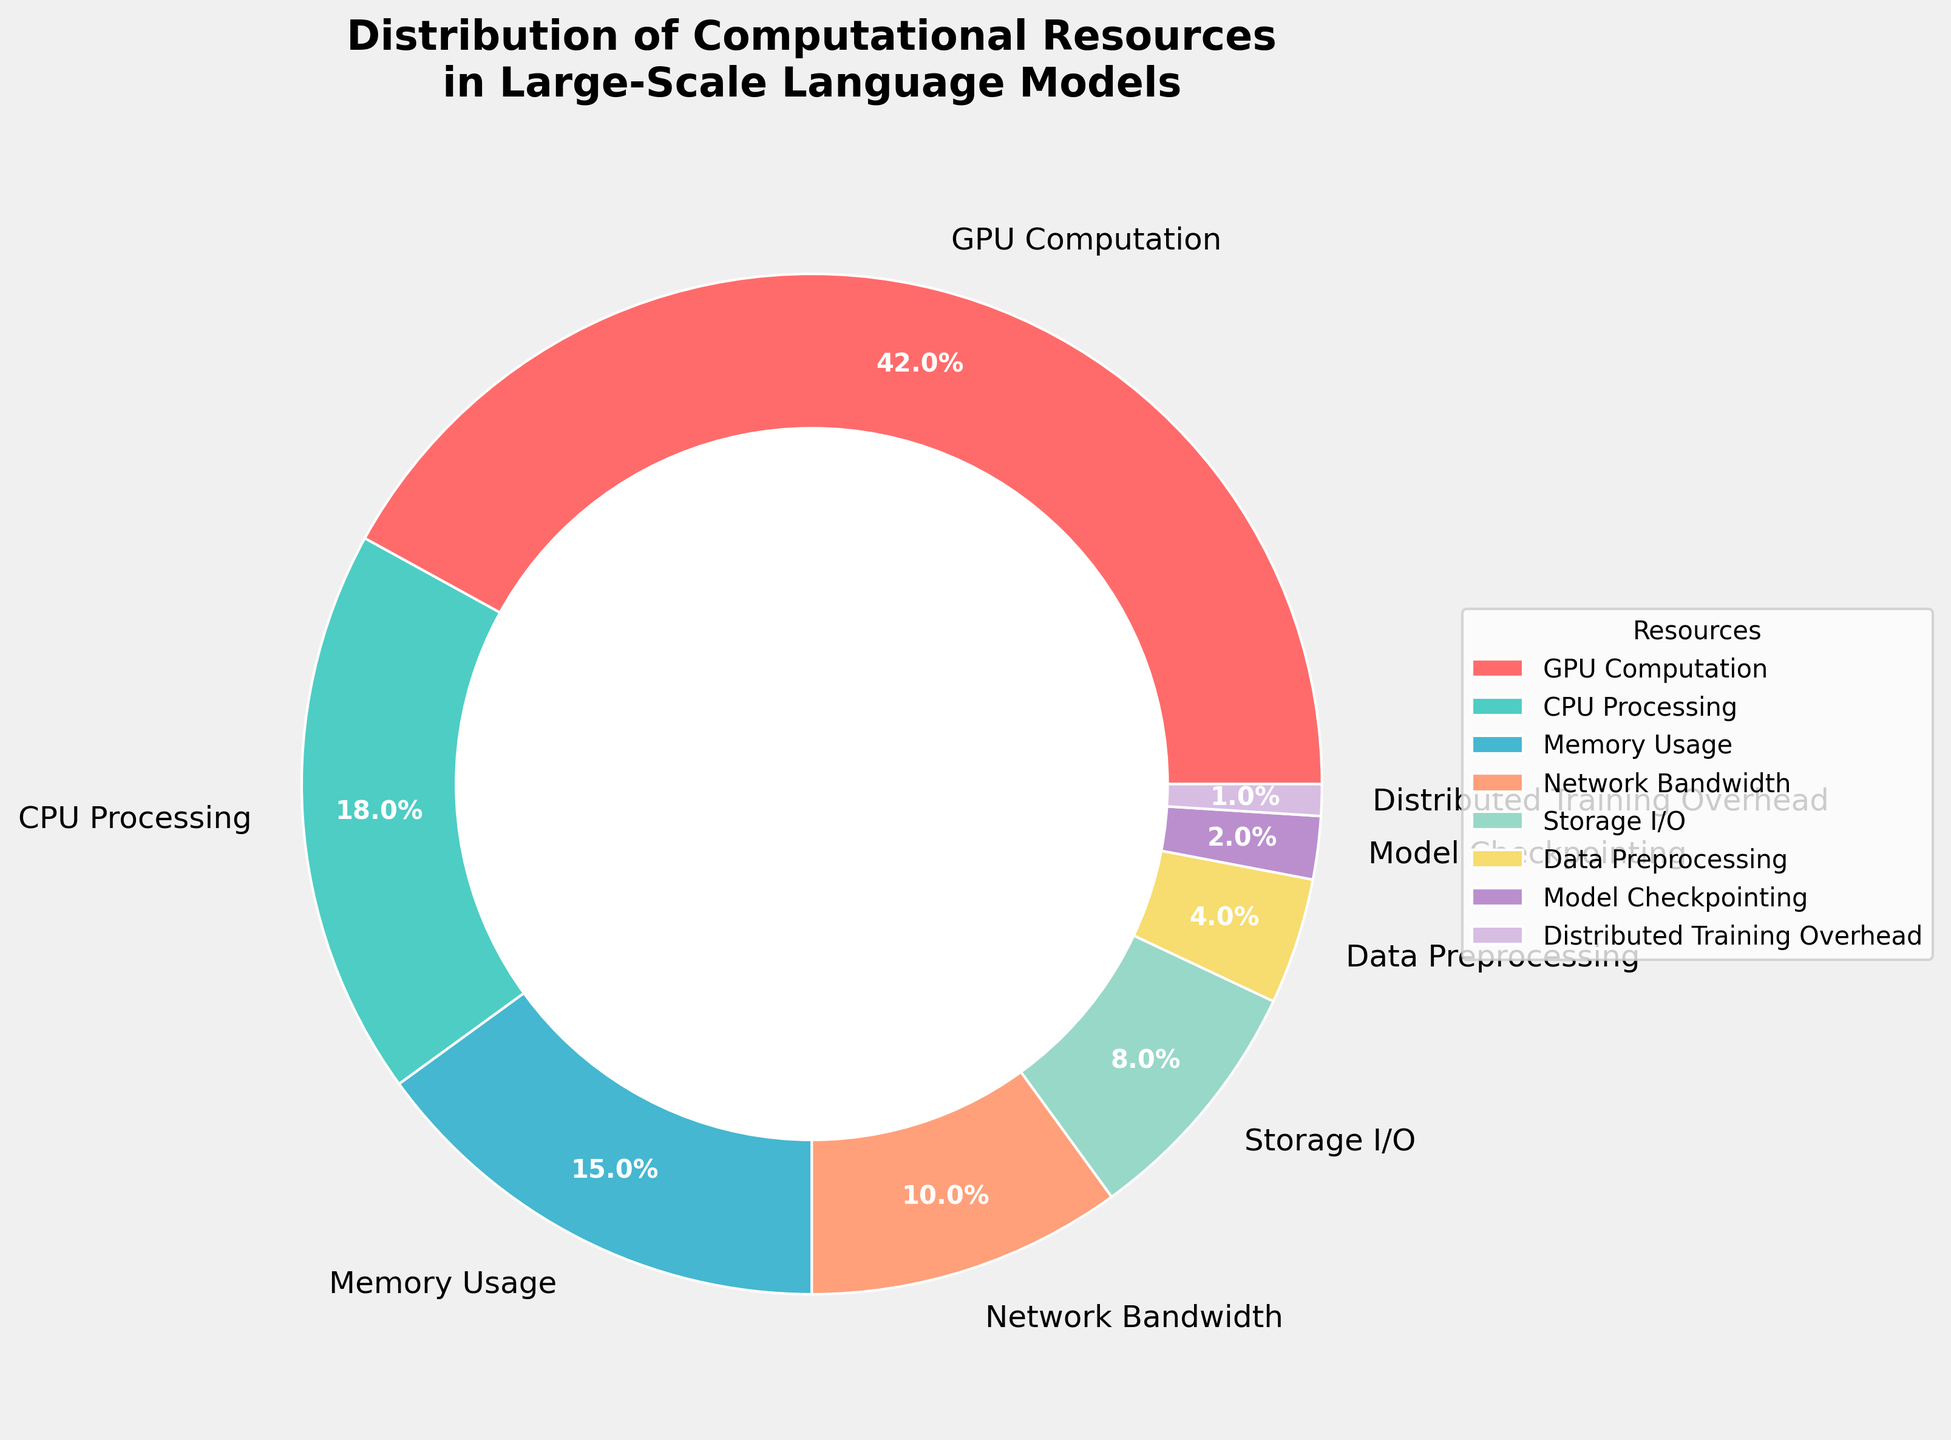What is the largest category of computational resource utilization? To determine the largest category, look at the sections of the pie chart and find the one with the highest percentage. The "GPU Computation" section occupies the largest part of the chart with 42%.
Answer: GPU Computation By how much does CPU Processing utilization exceed Memory Usage? Locate the "CPU Processing" and "Memory Usage" sections in the pie chart. CPU Processing has 18% while Memory Usage has 15%. Subtract the percentages: 18% - 15% = 3%.
Answer: 3% What is the combined percentage of Network Bandwidth and Storage I/O? Identify the segments for "Network Bandwidth" and "Storage I/O". Network Bandwidth is 10% and Storage I/O is 8%. Add them together: 10% + 8% = 18%.
Answer: 18% Which resource category accounts for the least percentage of computational resource utilization? Examine the segments for the smallest percentage. "Distributed Training Overhead" has the smallest slice at 1%.
Answer: Distributed Training Overhead How much higher is GPU Computation utilization compared to CPU Processing? Find the percentages for "GPU Computation" and "CPU Processing". GPU Computation is 42% while CPU Processing is 18%. Subtract 18% from 42%: 42% - 18% = 24%.
Answer: 24% Is the percentage of Data Preprocessing greater than, equal to, or less than Model Checkpointing? Locate "Data Preprocessing" and "Model Checkpointing" sections. Data Preprocessing is 4% and Model Checkpointing is 2%. Compare the two percentages: 4% is greater than 2%.
Answer: Greater Which two categories together make up more than 50% of the total resource utilization? Look for pairs of categories that sum to more than 50%. "GPU Computation" (42%) alone already occupies a large portion. Adding "CPU Processing" (18%) results in 42% + 18% = 60%.
Answer: GPU Computation and CPU Processing Calculate the total contribution of CPU Processing, Memory Usage, and Storage I/O to the overall distribution. Identify the percentages: CPU Processing (18%), Memory Usage (15%), and Storage I/O (8%). Add them together: 18% + 15% + 8% = 41%.
Answer: 41% Which section has a slice that is the fifth largest in the pie chart? Rank the percentages from largest to smallest: GPU Computation (42%), CPU Processing (18%), Memory Usage (15%), Network Bandwidth (10%), Storage I/O (8%). The fifth largest is Storage I/O.
Answer: Storage I/O 